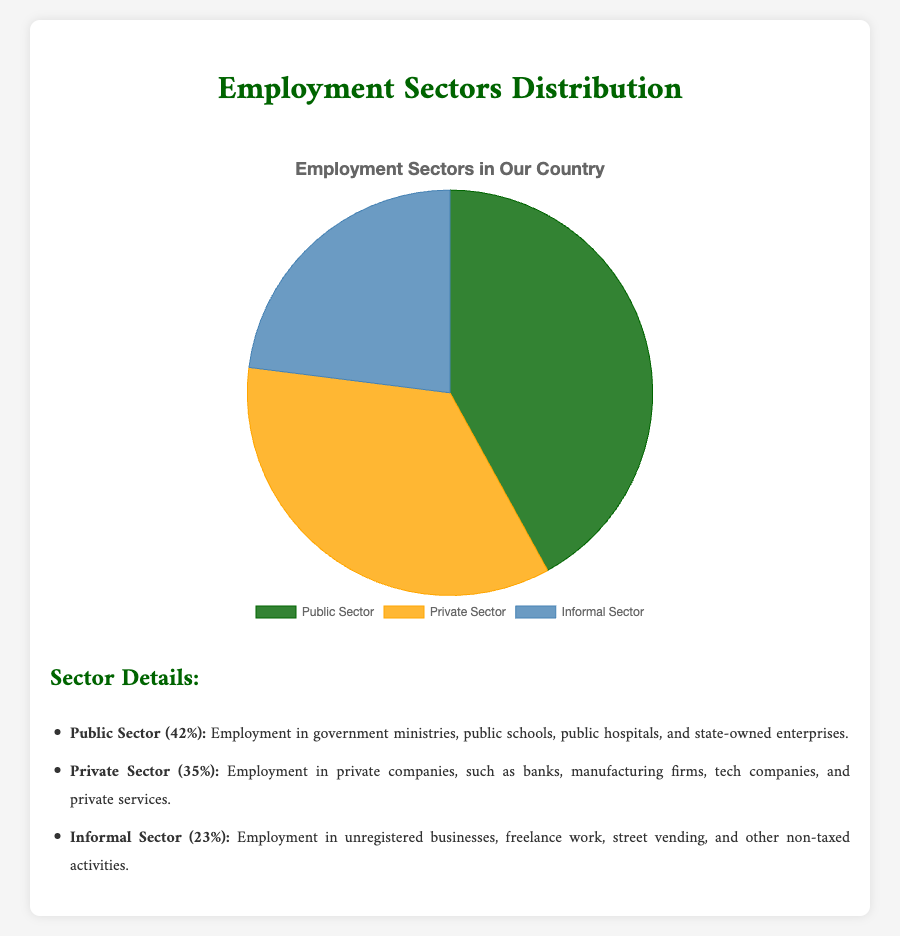what is the percentage of employment in the Public Sector? The chart shows that the Public Sector employment is 42%. This is directly visible on the pie chart where the Public Sector section is marked and labeled with its percentage.
Answer: 42% Which sector has the lowest employment percentage? By observing the pie chart, the sector with the smallest portion is the Informal Sector which is labeled with 23%.
Answer: Informal Sector What is the difference in employment percentages between the Public and Private sectors? The Public Sector has 42% employment and the Private Sector has 35% employment. The difference is calculated by subtracting 35% from 42%, which gives 7%.
Answer: 7% Which two sectors combined have more than 50% employment? The Public Sector has 42% and the Private Sector has 35%. Adding these two percentages, 42% + 35%, results in 77%, which is more than 50%.
Answer: Public and Private Sectors What is the total percentage of employment in the Private and Informal sectors together? The Private Sector has 35% employment and the Informal Sector has 23% employment. Adding these two percentages, 35% + 23%, results in 58%.
Answer: 58% Which sector's percentage of employment is closest to one-third of the total? One-third of 100% is approximately 33.33%. The Private Sector at 35% is the closest to this figure.
Answer: Private Sector Arrange the sectors in descending order of their employment percentages. The sectors are ordered as follows: Public Sector (42%), Private Sector (35%), Informal Sector (23%). This order is derived by comparing the percentages directly from the pie chart.
Answer: Public Sector, Private Sector, Informal Sector If the employment percentages are rounded to the nearest multiple of 5, how will the percentages change? Public Sector (42%) rounds to 40%, Private Sector (35%) stays at 35%, and Informal Sector (23%) rounds to 25%. This rounding is based on the closest multiple of 5.
Answer: Public Sector: 40%, Private Sector: 35%, Informal Sector: 25% How much greater is the employment percentage in the Public Sector compared to the Informal Sector? The Public Sector has 42% employment and the Informal Sector has 23% employment. The difference is calculated by subtracting 23% from 42%, which gives 19%.
Answer: 19% What proportion of employment is in sectors other than the Public Sector? The total percentage of employment is 100%. The Public Sector alone is 42%, so the remaining sectors (Private and Informal) comprise 100% - 42% = 58%.
Answer: 58% 